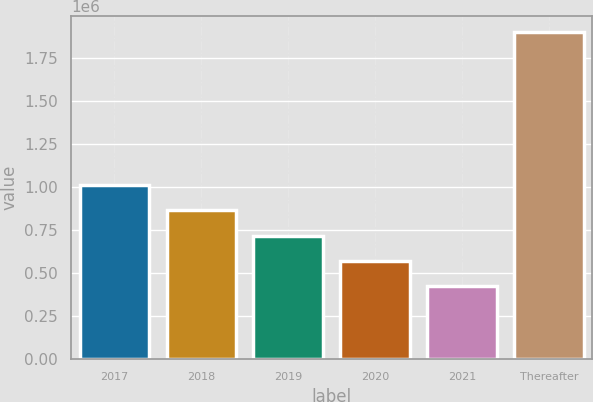Convert chart. <chart><loc_0><loc_0><loc_500><loc_500><bar_chart><fcel>2017<fcel>2018<fcel>2019<fcel>2020<fcel>2021<fcel>Thereafter<nl><fcel>1.01248e+06<fcel>864822<fcel>717166<fcel>569511<fcel>421855<fcel>1.89841e+06<nl></chart> 